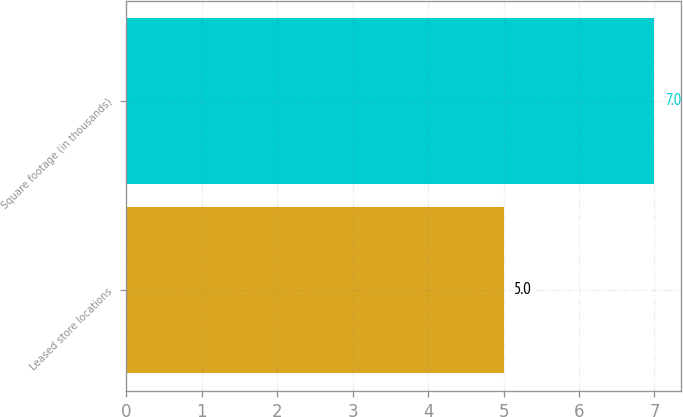Convert chart. <chart><loc_0><loc_0><loc_500><loc_500><bar_chart><fcel>Leased store locations<fcel>Square footage (in thousands)<nl><fcel>5<fcel>7<nl></chart> 